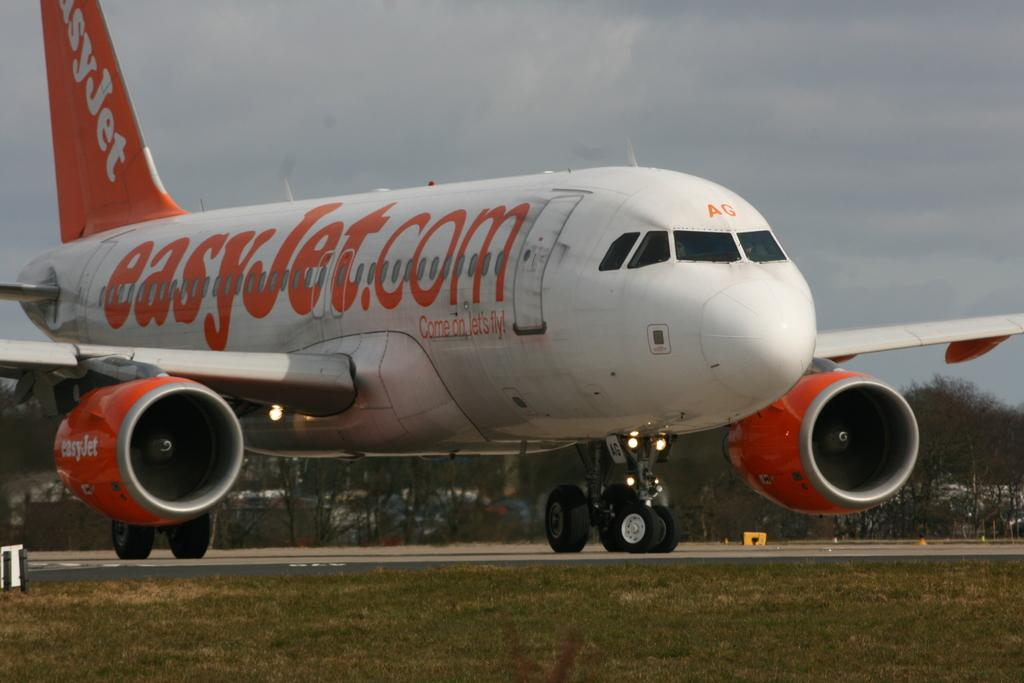What is the main subject of the image? The main subject of the image is an airplane on the runway. What can be seen in the background of the image? There are trees and the sky visible in the background of the image. What type of terrain is at the bottom of the image? There is grass at the bottom of the image. How many days does the airplane need to wash and lock itself in the image? The airplane does not wash or lock itself in the image; it is a static representation of an airplane on a runway. 